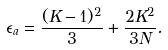<formula> <loc_0><loc_0><loc_500><loc_500>\epsilon _ { a } = \frac { ( K - 1 ) ^ { 2 } } { 3 } + \frac { 2 K ^ { 2 } } { 3 N } .</formula> 